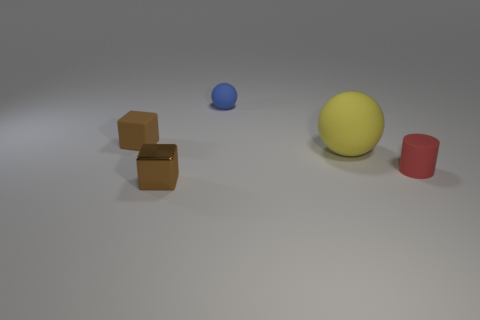Add 4 big blue cylinders. How many objects exist? 9 Subtract 1 balls. How many balls are left? 1 Subtract all cyan spheres. Subtract all cyan cylinders. How many spheres are left? 2 Subtract all green cubes. How many yellow balls are left? 1 Subtract all small brown metallic blocks. Subtract all tiny brown matte objects. How many objects are left? 3 Add 1 brown metallic blocks. How many brown metallic blocks are left? 2 Add 2 yellow objects. How many yellow objects exist? 3 Subtract 0 yellow cylinders. How many objects are left? 5 Subtract all cylinders. How many objects are left? 4 